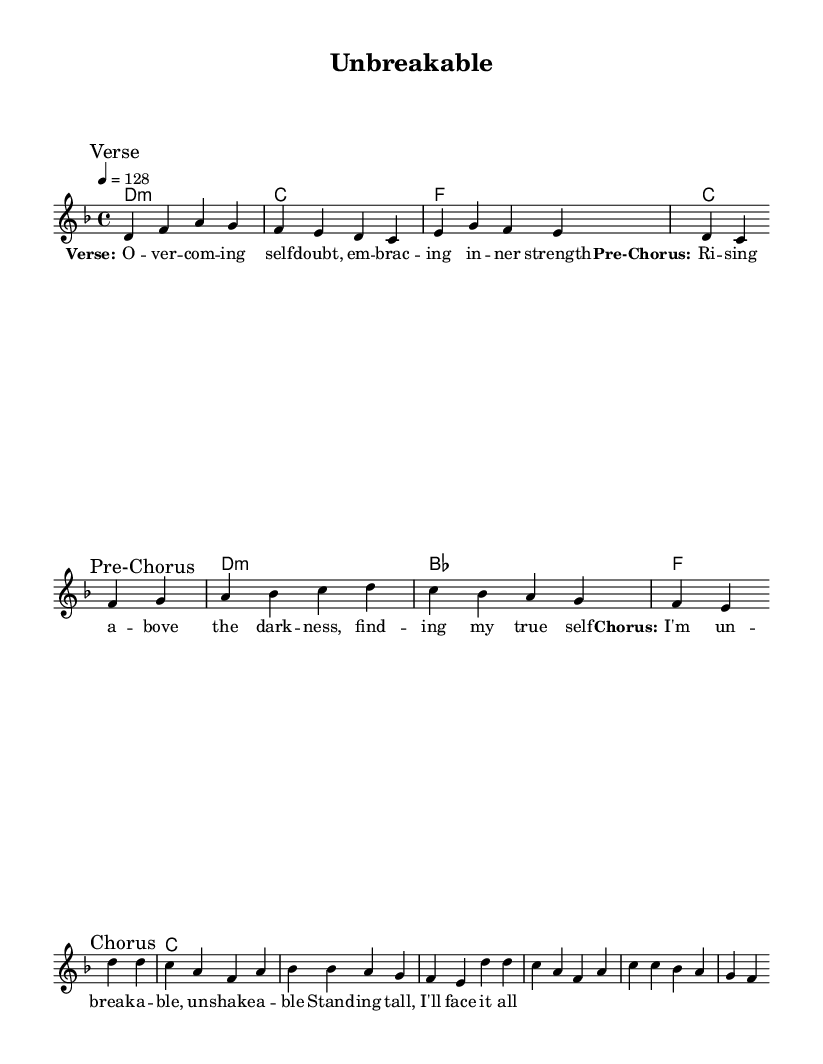What is the key signature of this music? The key signature is D minor, which is indicated by one flat (B flat). D minor also includes the notes D, E, F, G, A, B flat, and C.
Answer: D minor What is the time signature of this music? The time signature is 4/4, which means there are four beats in each measure, and the quarter note gets one beat. This is displayed at the beginning of the piece after the clef and key signature.
Answer: 4/4 What is the tempo marking for this piece? The tempo marking, indicated as "4 = 128," means the piece should be played at a speed of 128 beats per minute. This marking indicates the tempo in beats per minute.
Answer: 128 What is the first chord in the score? The first chord indicated in the chord names is D minor, which is represented as "d1:m," meaning it is a D minor chord that lasts for one whole measure.
Answer: D minor How many measures are in the Chorus section? The Chorus section consists of 4 measures, as indicated by the grouping of notes in that section. The first and second lines of the Chorus each contain two measures, totaling four measures overall.
Answer: 4 What is the main message conveyed in the lyrics? The lyrics focus on themes of resilience and self-empowerment, expressing overcoming self-doubt, rising above difficulties, and standing tall, which is a common theme in K-Pop narratives about personal struggles.
Answer: Empowerment 